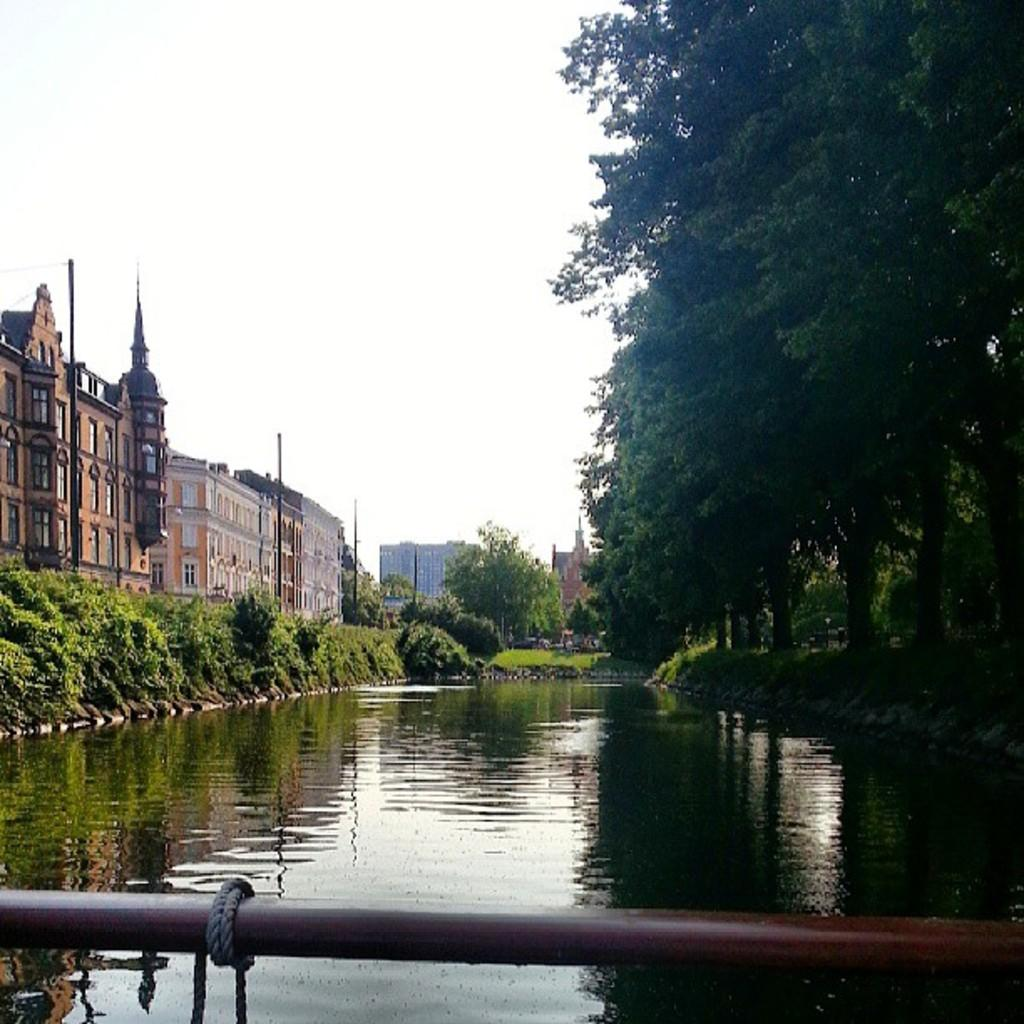What is visible in the image? Water, trees, buildings, poles, and the sky are visible in the image. Can you describe the natural elements in the image? There are trees visible in the image. What can be seen in the background of the image? There are buildings and poles in the background of the image. What part of the natural environment is visible in the image? The sky is visible in the background of the image. Can you see any bubbles floating in the water in the image? There is no mention of bubbles in the image, so we cannot determine if any bubbles are present. Is there a bee buzzing around the trees in the image? There is no mention of a bee in the image, so we cannot determine if any bees are present. 